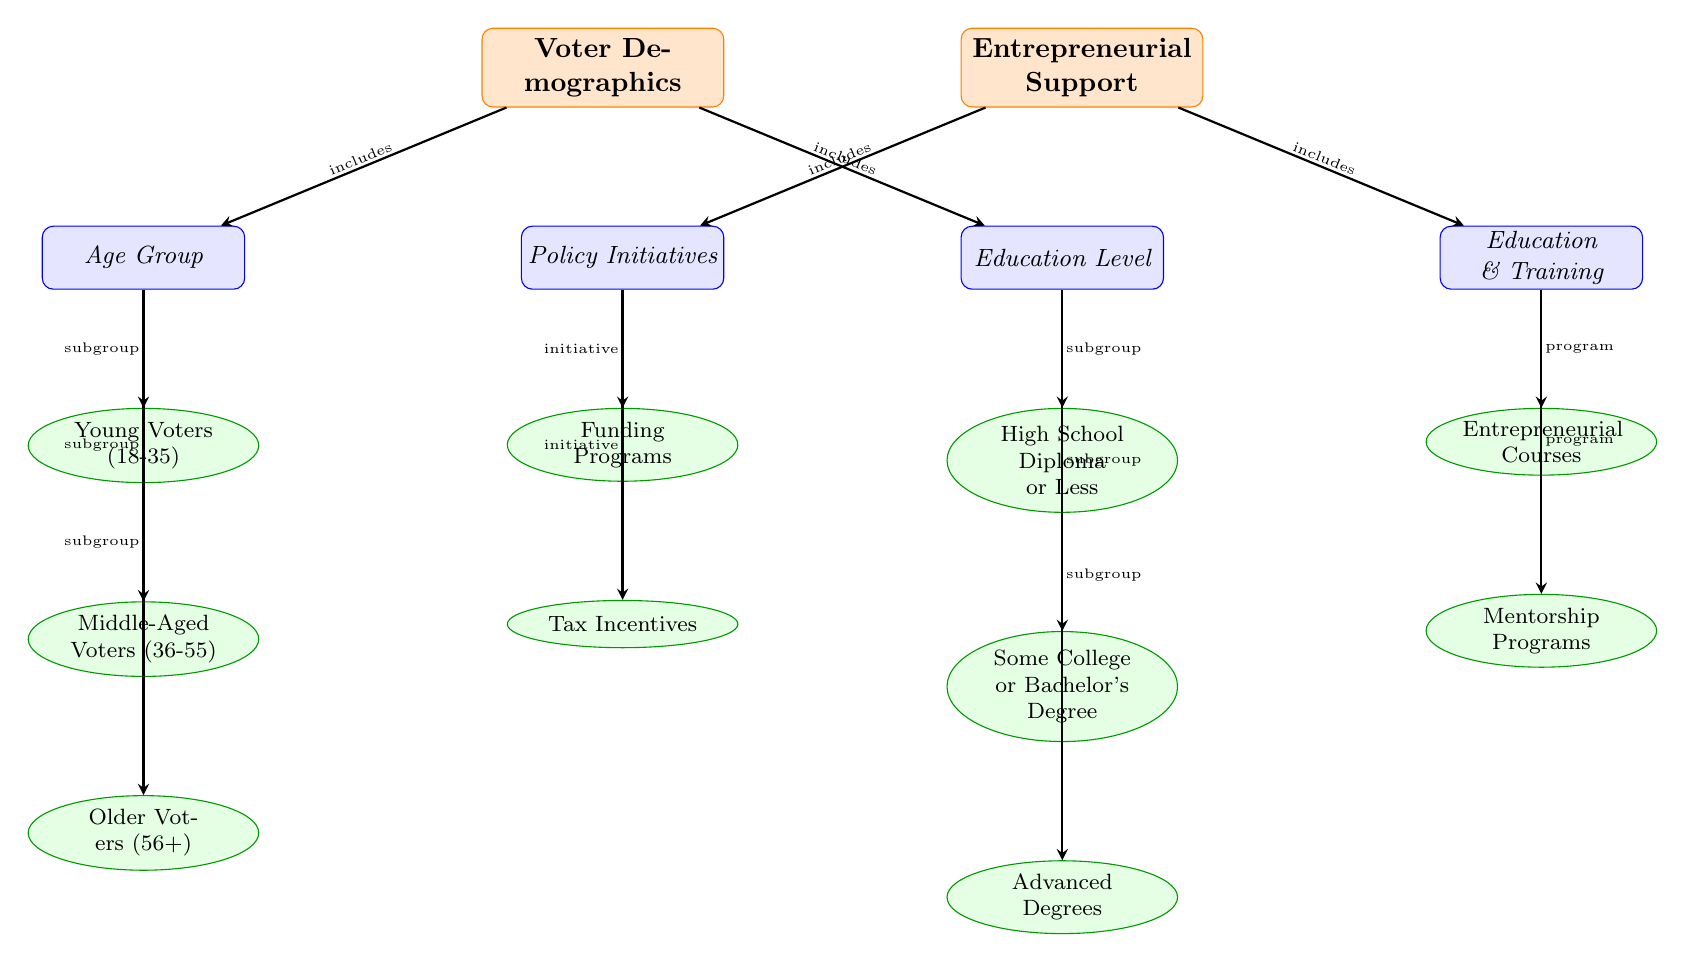What are the two main categories represented in the diagram? The diagram has two main categories at the top: Voter Demographics and Entrepreneurial Support. These categories are separated by a line in the visual representation.
Answer: Voter Demographics, Entrepreneurial Support How many subcategories are under Voter Demographics? There are two subcategories under Voter Demographics: Age Group and Education Level. This can be observed through the lines connecting the main category to these subcategories.
Answer: 2 What are the three subgroups under the Age Group category? The subgroups listed under Age Group are Young Voters (18-35), Middle-Aged Voters (36-55), and Older Voters (56+). Each subgroup is connected directly to the Age Group subcategory node.
Answer: Young Voters (18-35), Middle-Aged Voters (36-55), Older Voters (56+) Which initiative is connected to Funding Programs? The Funding Programs node is directly connected to the Policy Initiatives subcategory, indicating that it is a specific initiative aimed at supporting entrepreneurs.
Answer: Policy Initiatives What is the relationship between Entrepreneurial Support and Education & Training? Entrepreneurial Support includes the Education & Training subcategory, which implies that there are programs related to entrepreneurial training under this support category.
Answer: includes What is the total number of edges in the diagram? By counting the arrows (edges) that connect the nodes, we see there are a total of 10 edges that link various categories, subcategories, and entities in the diagram.
Answer: 10 What kind of subgroups are classified under Education Level? The Education Level subcategory contains three subgroups: High School Diploma or Less, Some College or Bachelor's Degree, and Advanced Degrees, each represented in the diagram.
Answer: High School Diploma or Less, Some College or Bachelor's Degree, Advanced Degrees Which program is specifically linked to Education & Training? The Education & Training subcategory has two programs linked to it: Entrepreneurial Courses and Mentorship Programs, thereby providing specific aspects of educational support for entrepreneurs.
Answer: Entrepreneurial Courses, Mentorship Programs Identify the two specific types of initiatives under the Policy Initiatives category. The diagram shows two initiatives under Policy Initiatives, which are Funding Programs and Tax Incentives. These are clear entities that support entrepreneur endeavors.
Answer: Funding Programs, Tax Incentives 